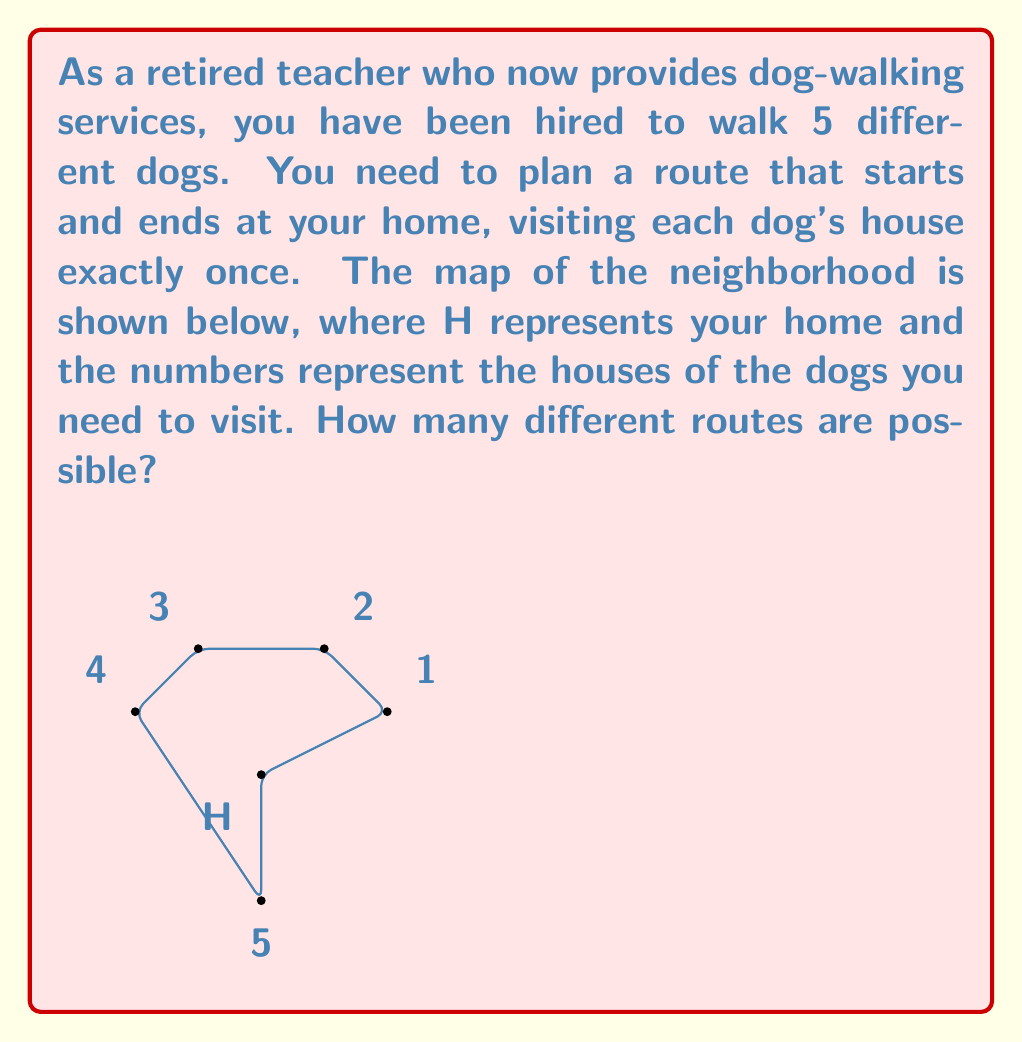Help me with this question. Let's approach this step-by-step:

1) This problem is an application of permutations. We need to determine how many ways we can arrange the 5 dog houses in a sequence.

2) The key observation is that our starting and ending point (our home) is fixed. We only need to consider the order in which we visit the 5 dog houses.

3) This is a straightforward permutation problem. We have 5 distinct elements (the dog houses) and we need to arrange all of them.

4) The number of permutations of n distinct objects is given by the formula:

   $$P(n) = n!$$

   Where $n!$ represents the factorial of $n$.

5) In this case, $n = 5$, so we need to calculate $5!$:

   $$5! = 5 \times 4 \times 3 \times 2 \times 1 = 120$$

6) Therefore, there are 120 different possible routes to walk the dogs.

Note: Each route starts at your home (H), visits each dog's house exactly once in some order, and then returns to your home. The order of visiting the dog houses determines the unique route.
Answer: 120 